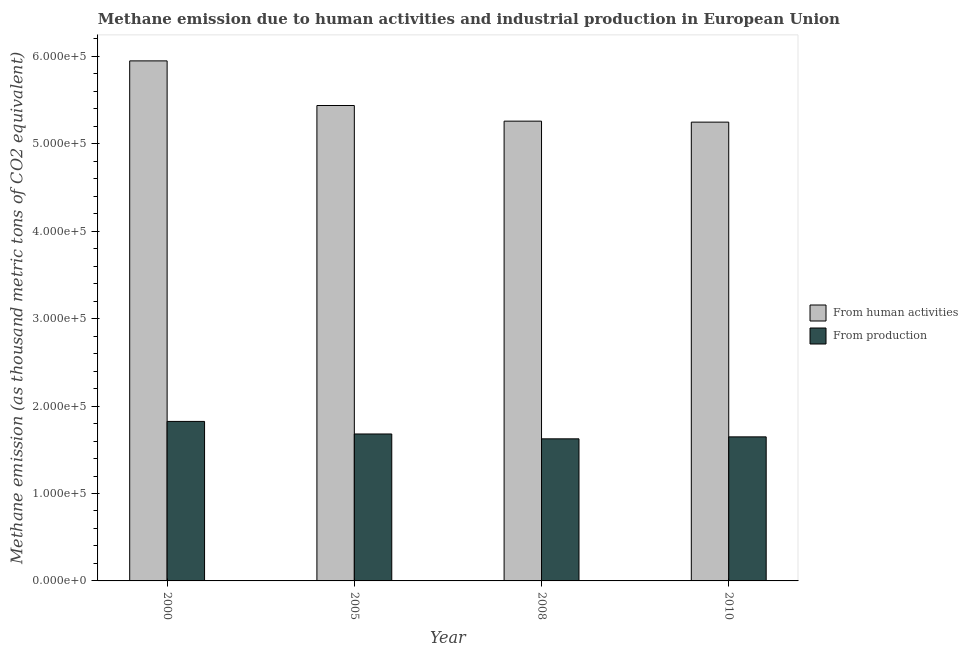How many different coloured bars are there?
Your answer should be compact. 2. How many groups of bars are there?
Ensure brevity in your answer.  4. How many bars are there on the 2nd tick from the right?
Your answer should be compact. 2. What is the label of the 3rd group of bars from the left?
Keep it short and to the point. 2008. In how many cases, is the number of bars for a given year not equal to the number of legend labels?
Make the answer very short. 0. What is the amount of emissions from human activities in 2010?
Provide a short and direct response. 5.25e+05. Across all years, what is the maximum amount of emissions from human activities?
Keep it short and to the point. 5.95e+05. Across all years, what is the minimum amount of emissions from human activities?
Provide a succinct answer. 5.25e+05. In which year was the amount of emissions from human activities maximum?
Provide a succinct answer. 2000. What is the total amount of emissions generated from industries in the graph?
Provide a short and direct response. 6.78e+05. What is the difference between the amount of emissions generated from industries in 2005 and that in 2010?
Offer a very short reply. 3298.2. What is the difference between the amount of emissions from human activities in 2000 and the amount of emissions generated from industries in 2010?
Keep it short and to the point. 7.01e+04. What is the average amount of emissions from human activities per year?
Your answer should be compact. 5.47e+05. In the year 2010, what is the difference between the amount of emissions generated from industries and amount of emissions from human activities?
Ensure brevity in your answer.  0. In how many years, is the amount of emissions from human activities greater than 580000 thousand metric tons?
Offer a very short reply. 1. What is the ratio of the amount of emissions from human activities in 2005 to that in 2010?
Your answer should be compact. 1.04. What is the difference between the highest and the second highest amount of emissions from human activities?
Provide a short and direct response. 5.10e+04. What is the difference between the highest and the lowest amount of emissions generated from industries?
Provide a succinct answer. 1.99e+04. In how many years, is the amount of emissions generated from industries greater than the average amount of emissions generated from industries taken over all years?
Your answer should be very brief. 1. What does the 2nd bar from the left in 2008 represents?
Provide a succinct answer. From production. What does the 2nd bar from the right in 2008 represents?
Offer a terse response. From human activities. How many years are there in the graph?
Keep it short and to the point. 4. Does the graph contain grids?
Ensure brevity in your answer.  No. How many legend labels are there?
Make the answer very short. 2. What is the title of the graph?
Give a very brief answer. Methane emission due to human activities and industrial production in European Union. What is the label or title of the X-axis?
Offer a very short reply. Year. What is the label or title of the Y-axis?
Offer a very short reply. Methane emission (as thousand metric tons of CO2 equivalent). What is the Methane emission (as thousand metric tons of CO2 equivalent) of From human activities in 2000?
Make the answer very short. 5.95e+05. What is the Methane emission (as thousand metric tons of CO2 equivalent) in From production in 2000?
Your answer should be compact. 1.82e+05. What is the Methane emission (as thousand metric tons of CO2 equivalent) in From human activities in 2005?
Keep it short and to the point. 5.44e+05. What is the Methane emission (as thousand metric tons of CO2 equivalent) in From production in 2005?
Provide a succinct answer. 1.68e+05. What is the Methane emission (as thousand metric tons of CO2 equivalent) in From human activities in 2008?
Provide a succinct answer. 5.26e+05. What is the Methane emission (as thousand metric tons of CO2 equivalent) in From production in 2008?
Your response must be concise. 1.63e+05. What is the Methane emission (as thousand metric tons of CO2 equivalent) in From human activities in 2010?
Ensure brevity in your answer.  5.25e+05. What is the Methane emission (as thousand metric tons of CO2 equivalent) in From production in 2010?
Make the answer very short. 1.65e+05. Across all years, what is the maximum Methane emission (as thousand metric tons of CO2 equivalent) in From human activities?
Your answer should be compact. 5.95e+05. Across all years, what is the maximum Methane emission (as thousand metric tons of CO2 equivalent) in From production?
Provide a succinct answer. 1.82e+05. Across all years, what is the minimum Methane emission (as thousand metric tons of CO2 equivalent) in From human activities?
Your answer should be compact. 5.25e+05. Across all years, what is the minimum Methane emission (as thousand metric tons of CO2 equivalent) of From production?
Offer a very short reply. 1.63e+05. What is the total Methane emission (as thousand metric tons of CO2 equivalent) of From human activities in the graph?
Ensure brevity in your answer.  2.19e+06. What is the total Methane emission (as thousand metric tons of CO2 equivalent) of From production in the graph?
Provide a short and direct response. 6.78e+05. What is the difference between the Methane emission (as thousand metric tons of CO2 equivalent) in From human activities in 2000 and that in 2005?
Provide a succinct answer. 5.10e+04. What is the difference between the Methane emission (as thousand metric tons of CO2 equivalent) of From production in 2000 and that in 2005?
Your answer should be compact. 1.44e+04. What is the difference between the Methane emission (as thousand metric tons of CO2 equivalent) of From human activities in 2000 and that in 2008?
Your answer should be very brief. 6.89e+04. What is the difference between the Methane emission (as thousand metric tons of CO2 equivalent) in From production in 2000 and that in 2008?
Your answer should be compact. 1.99e+04. What is the difference between the Methane emission (as thousand metric tons of CO2 equivalent) in From human activities in 2000 and that in 2010?
Make the answer very short. 7.01e+04. What is the difference between the Methane emission (as thousand metric tons of CO2 equivalent) of From production in 2000 and that in 2010?
Offer a very short reply. 1.77e+04. What is the difference between the Methane emission (as thousand metric tons of CO2 equivalent) of From human activities in 2005 and that in 2008?
Give a very brief answer. 1.79e+04. What is the difference between the Methane emission (as thousand metric tons of CO2 equivalent) of From production in 2005 and that in 2008?
Your answer should be very brief. 5562. What is the difference between the Methane emission (as thousand metric tons of CO2 equivalent) in From human activities in 2005 and that in 2010?
Give a very brief answer. 1.90e+04. What is the difference between the Methane emission (as thousand metric tons of CO2 equivalent) in From production in 2005 and that in 2010?
Offer a terse response. 3298.2. What is the difference between the Methane emission (as thousand metric tons of CO2 equivalent) of From human activities in 2008 and that in 2010?
Offer a terse response. 1133.4. What is the difference between the Methane emission (as thousand metric tons of CO2 equivalent) of From production in 2008 and that in 2010?
Provide a short and direct response. -2263.8. What is the difference between the Methane emission (as thousand metric tons of CO2 equivalent) of From human activities in 2000 and the Methane emission (as thousand metric tons of CO2 equivalent) of From production in 2005?
Ensure brevity in your answer.  4.27e+05. What is the difference between the Methane emission (as thousand metric tons of CO2 equivalent) of From human activities in 2000 and the Methane emission (as thousand metric tons of CO2 equivalent) of From production in 2008?
Your response must be concise. 4.32e+05. What is the difference between the Methane emission (as thousand metric tons of CO2 equivalent) of From human activities in 2000 and the Methane emission (as thousand metric tons of CO2 equivalent) of From production in 2010?
Ensure brevity in your answer.  4.30e+05. What is the difference between the Methane emission (as thousand metric tons of CO2 equivalent) in From human activities in 2005 and the Methane emission (as thousand metric tons of CO2 equivalent) in From production in 2008?
Offer a terse response. 3.81e+05. What is the difference between the Methane emission (as thousand metric tons of CO2 equivalent) of From human activities in 2005 and the Methane emission (as thousand metric tons of CO2 equivalent) of From production in 2010?
Provide a short and direct response. 3.79e+05. What is the difference between the Methane emission (as thousand metric tons of CO2 equivalent) of From human activities in 2008 and the Methane emission (as thousand metric tons of CO2 equivalent) of From production in 2010?
Keep it short and to the point. 3.61e+05. What is the average Methane emission (as thousand metric tons of CO2 equivalent) of From human activities per year?
Provide a short and direct response. 5.47e+05. What is the average Methane emission (as thousand metric tons of CO2 equivalent) of From production per year?
Offer a terse response. 1.69e+05. In the year 2000, what is the difference between the Methane emission (as thousand metric tons of CO2 equivalent) of From human activities and Methane emission (as thousand metric tons of CO2 equivalent) of From production?
Keep it short and to the point. 4.12e+05. In the year 2005, what is the difference between the Methane emission (as thousand metric tons of CO2 equivalent) of From human activities and Methane emission (as thousand metric tons of CO2 equivalent) of From production?
Your answer should be very brief. 3.76e+05. In the year 2008, what is the difference between the Methane emission (as thousand metric tons of CO2 equivalent) in From human activities and Methane emission (as thousand metric tons of CO2 equivalent) in From production?
Offer a very short reply. 3.63e+05. In the year 2010, what is the difference between the Methane emission (as thousand metric tons of CO2 equivalent) of From human activities and Methane emission (as thousand metric tons of CO2 equivalent) of From production?
Make the answer very short. 3.60e+05. What is the ratio of the Methane emission (as thousand metric tons of CO2 equivalent) of From human activities in 2000 to that in 2005?
Provide a succinct answer. 1.09. What is the ratio of the Methane emission (as thousand metric tons of CO2 equivalent) of From production in 2000 to that in 2005?
Your response must be concise. 1.09. What is the ratio of the Methane emission (as thousand metric tons of CO2 equivalent) of From human activities in 2000 to that in 2008?
Make the answer very short. 1.13. What is the ratio of the Methane emission (as thousand metric tons of CO2 equivalent) in From production in 2000 to that in 2008?
Keep it short and to the point. 1.12. What is the ratio of the Methane emission (as thousand metric tons of CO2 equivalent) of From human activities in 2000 to that in 2010?
Ensure brevity in your answer.  1.13. What is the ratio of the Methane emission (as thousand metric tons of CO2 equivalent) in From production in 2000 to that in 2010?
Ensure brevity in your answer.  1.11. What is the ratio of the Methane emission (as thousand metric tons of CO2 equivalent) of From human activities in 2005 to that in 2008?
Offer a terse response. 1.03. What is the ratio of the Methane emission (as thousand metric tons of CO2 equivalent) of From production in 2005 to that in 2008?
Keep it short and to the point. 1.03. What is the ratio of the Methane emission (as thousand metric tons of CO2 equivalent) of From human activities in 2005 to that in 2010?
Keep it short and to the point. 1.04. What is the ratio of the Methane emission (as thousand metric tons of CO2 equivalent) of From human activities in 2008 to that in 2010?
Provide a succinct answer. 1. What is the ratio of the Methane emission (as thousand metric tons of CO2 equivalent) of From production in 2008 to that in 2010?
Provide a succinct answer. 0.99. What is the difference between the highest and the second highest Methane emission (as thousand metric tons of CO2 equivalent) in From human activities?
Your response must be concise. 5.10e+04. What is the difference between the highest and the second highest Methane emission (as thousand metric tons of CO2 equivalent) in From production?
Give a very brief answer. 1.44e+04. What is the difference between the highest and the lowest Methane emission (as thousand metric tons of CO2 equivalent) in From human activities?
Provide a succinct answer. 7.01e+04. What is the difference between the highest and the lowest Methane emission (as thousand metric tons of CO2 equivalent) in From production?
Offer a very short reply. 1.99e+04. 